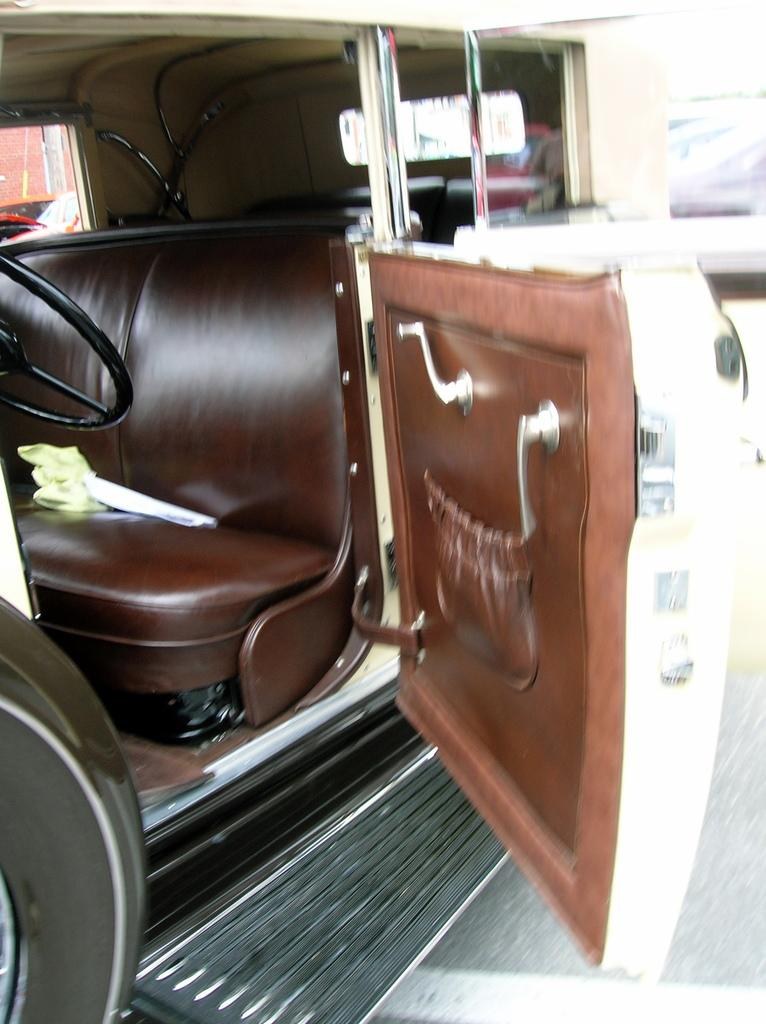What is the main subject of the image? The main subject of the image is a vehicle. What specific feature can be seen inside the vehicle? The vehicle has a steering wheel. What is present for the driver to sit on? The vehicle has a seat. How would you describe the background of the image? The background of the image is blurred. How many porters are assisting the sisters in the image? There are no porters or sisters present in the image; it features a vehicle with a steering wheel and seat. What type of men can be seen working on the vehicle in the image? There are no men working on the vehicle in the image; it is a stationary vehicle with a blurred background. 